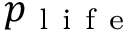<formula> <loc_0><loc_0><loc_500><loc_500>p _ { l i f e }</formula> 